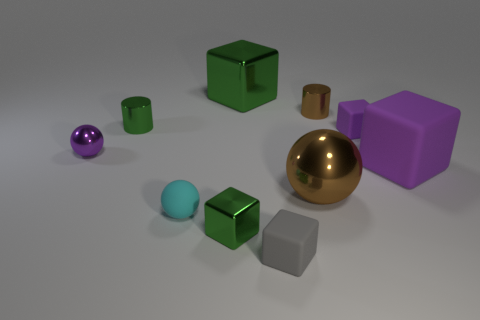Which objects in the picture are metallic? The objects that appear metallic in the image are the brown sphere and the small gold-colored cylinder. 